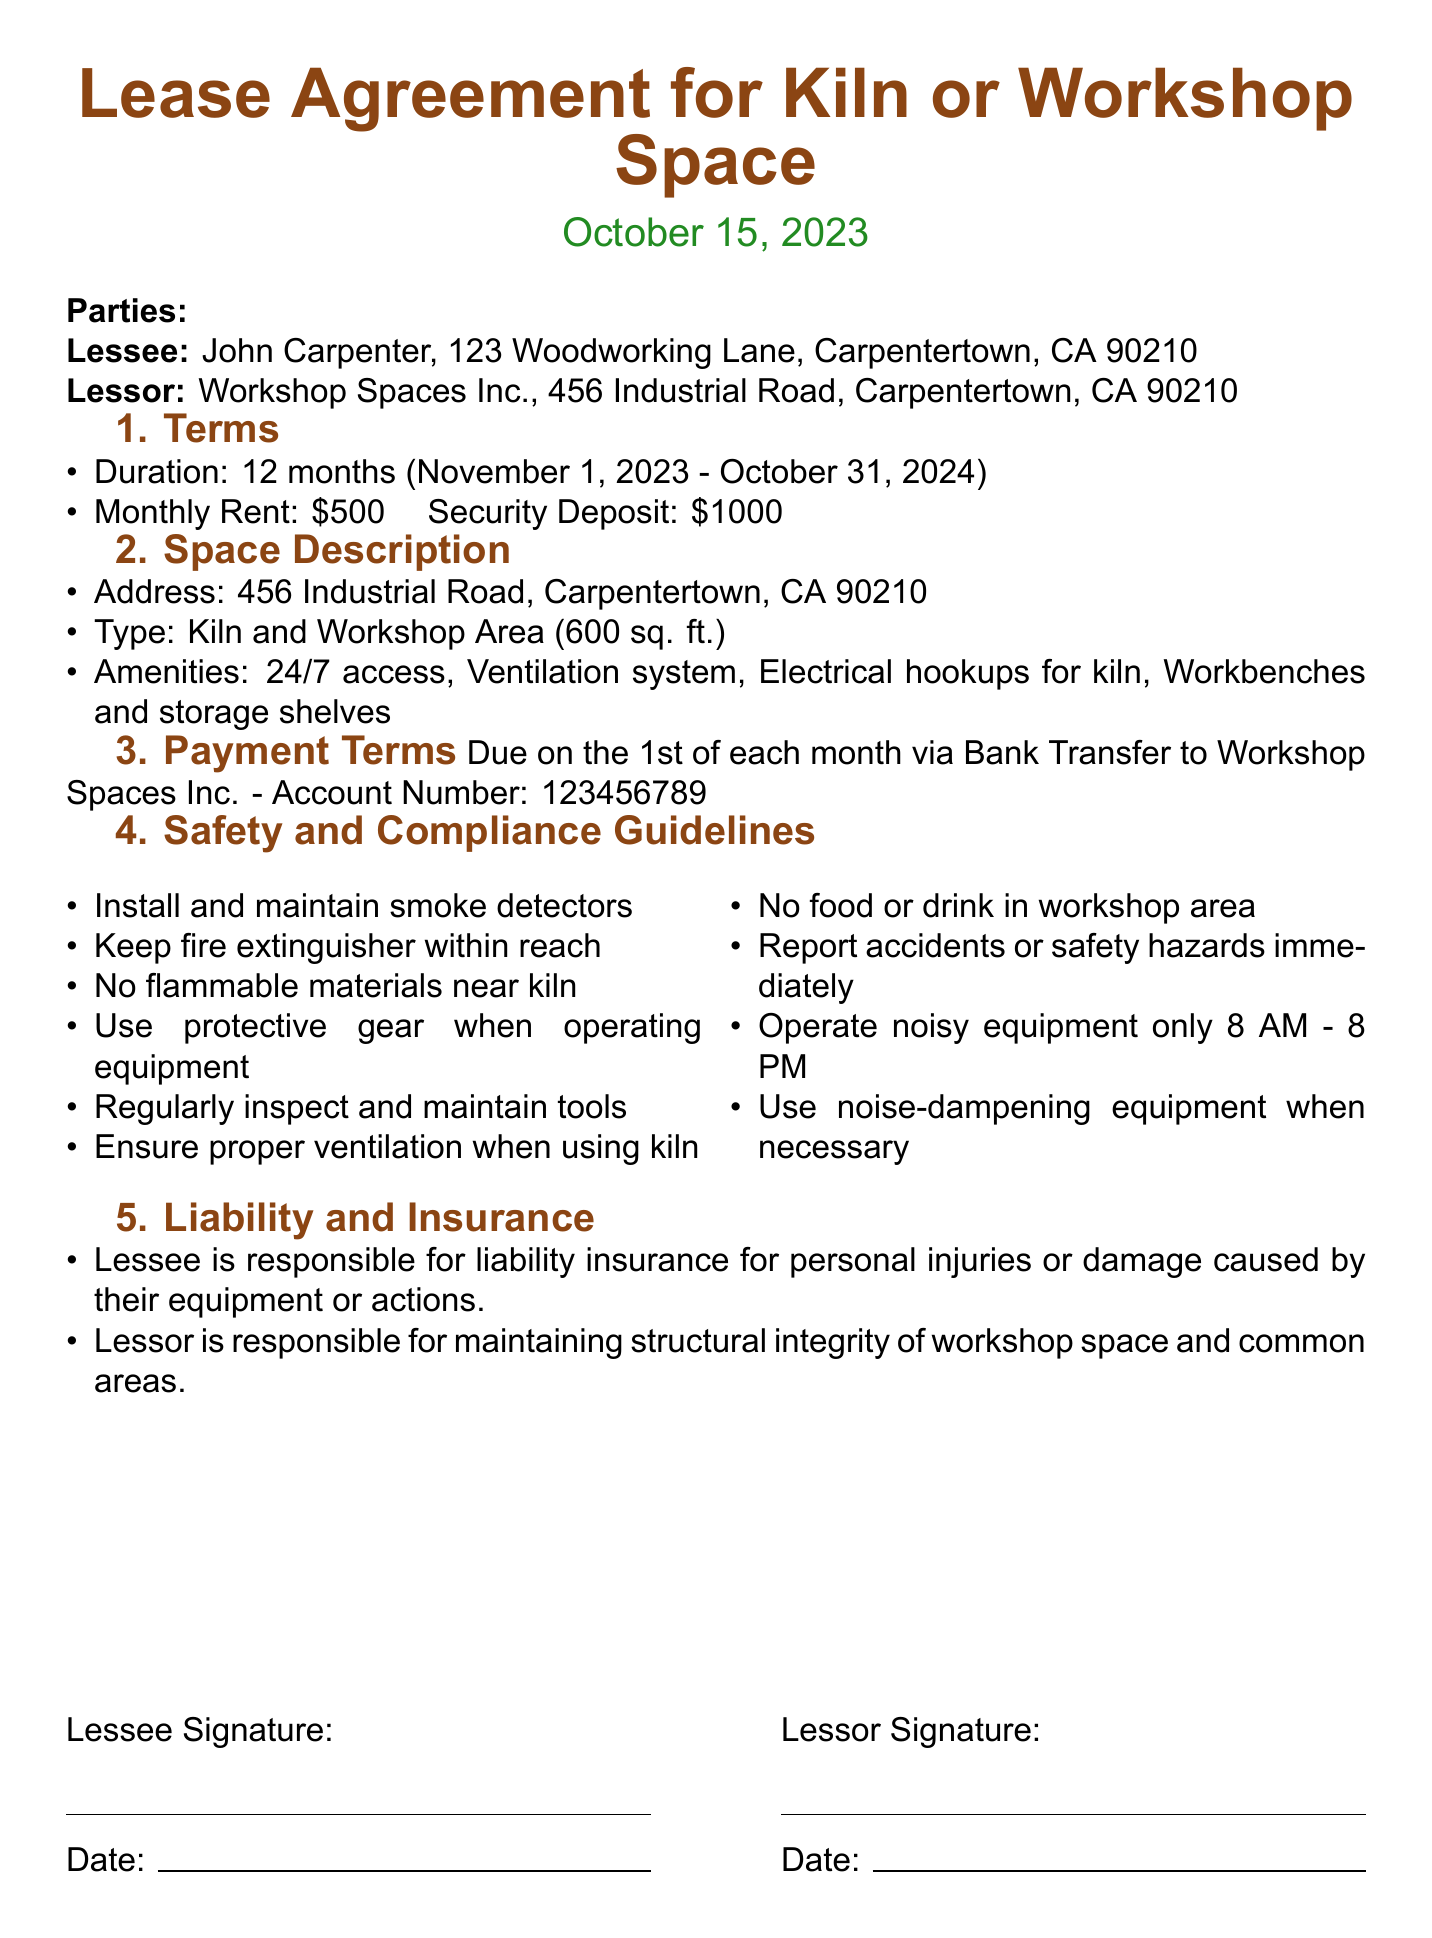What is the duration of the lease? The duration of the lease is specified in the "Terms" section of the document as 12 months.
Answer: 12 months Who is the Lessee? The "Parties" section identifies the Lessee as John Carpenter.
Answer: John Carpenter What is the monthly rent amount? The "Terms" section states the monthly rent amount.
Answer: $500 What type of space is being leased? The "Space Description" section specifies the type of space as a Kiln and Workshop Area.
Answer: Kiln and Workshop Area What is the security deposit amount? The "Terms" section mentions the security deposit amount required for the lease.
Answer: $1000 What must be kept within reach according to safety guidelines? The "Safety and Compliance Guidelines" section requires a fire extinguisher to be kept within reach.
Answer: Fire extinguisher What are the operating hours for noisy equipment? The "Safety and Compliance Guidelines" outline when noisy equipment can be operated.
Answer: 8 AM - 8 PM Who is responsible for liability insurance? The "Liability and Insurance" section states that the Lessee is responsible for liability insurance.
Answer: Lessee 